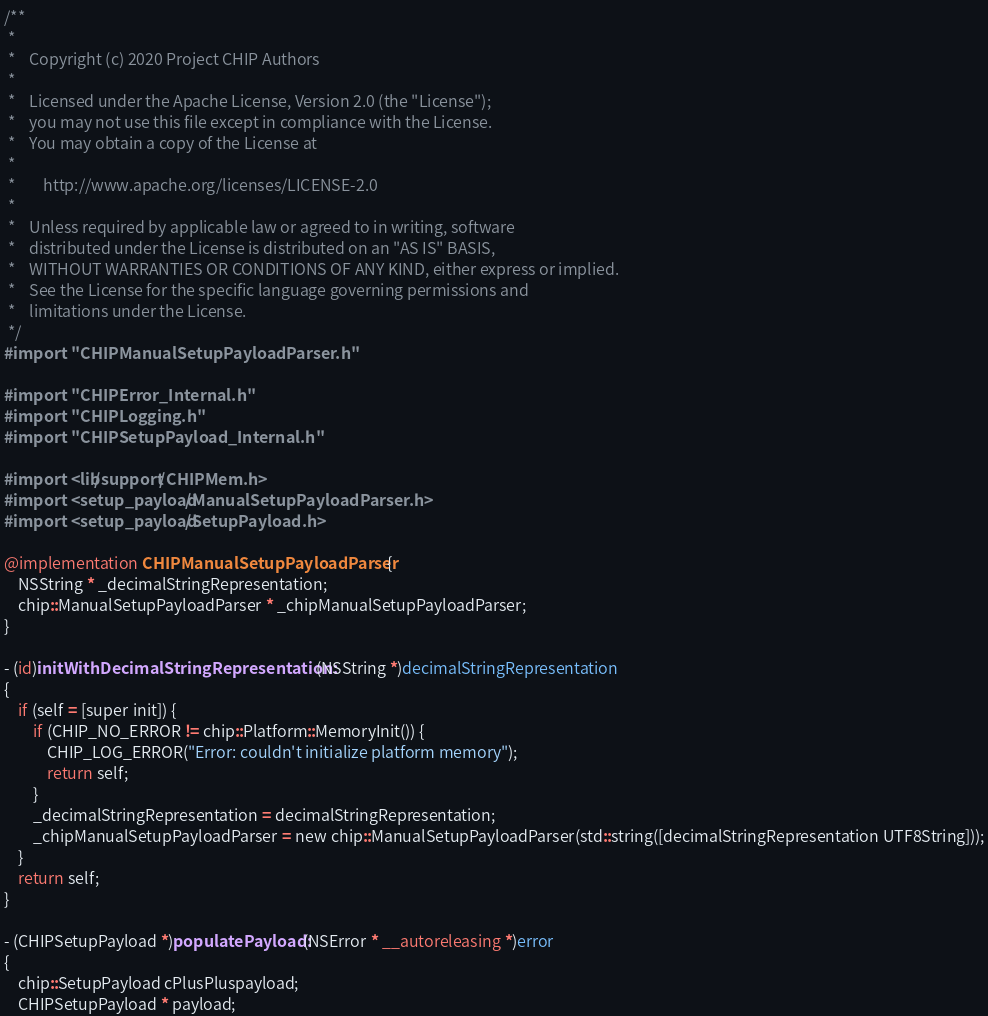<code> <loc_0><loc_0><loc_500><loc_500><_ObjectiveC_>/**
 *
 *    Copyright (c) 2020 Project CHIP Authors
 *
 *    Licensed under the Apache License, Version 2.0 (the "License");
 *    you may not use this file except in compliance with the License.
 *    You may obtain a copy of the License at
 *
 *        http://www.apache.org/licenses/LICENSE-2.0
 *
 *    Unless required by applicable law or agreed to in writing, software
 *    distributed under the License is distributed on an "AS IS" BASIS,
 *    WITHOUT WARRANTIES OR CONDITIONS OF ANY KIND, either express or implied.
 *    See the License for the specific language governing permissions and
 *    limitations under the License.
 */
#import "CHIPManualSetupPayloadParser.h"

#import "CHIPError_Internal.h"
#import "CHIPLogging.h"
#import "CHIPSetupPayload_Internal.h"

#import <lib/support/CHIPMem.h>
#import <setup_payload/ManualSetupPayloadParser.h>
#import <setup_payload/SetupPayload.h>

@implementation CHIPManualSetupPayloadParser {
    NSString * _decimalStringRepresentation;
    chip::ManualSetupPayloadParser * _chipManualSetupPayloadParser;
}

- (id)initWithDecimalStringRepresentation:(NSString *)decimalStringRepresentation
{
    if (self = [super init]) {
        if (CHIP_NO_ERROR != chip::Platform::MemoryInit()) {
            CHIP_LOG_ERROR("Error: couldn't initialize platform memory");
            return self;
        }
        _decimalStringRepresentation = decimalStringRepresentation;
        _chipManualSetupPayloadParser = new chip::ManualSetupPayloadParser(std::string([decimalStringRepresentation UTF8String]));
    }
    return self;
}

- (CHIPSetupPayload *)populatePayload:(NSError * __autoreleasing *)error
{
    chip::SetupPayload cPlusPluspayload;
    CHIPSetupPayload * payload;
</code> 